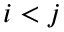<formula> <loc_0><loc_0><loc_500><loc_500>i < j</formula> 